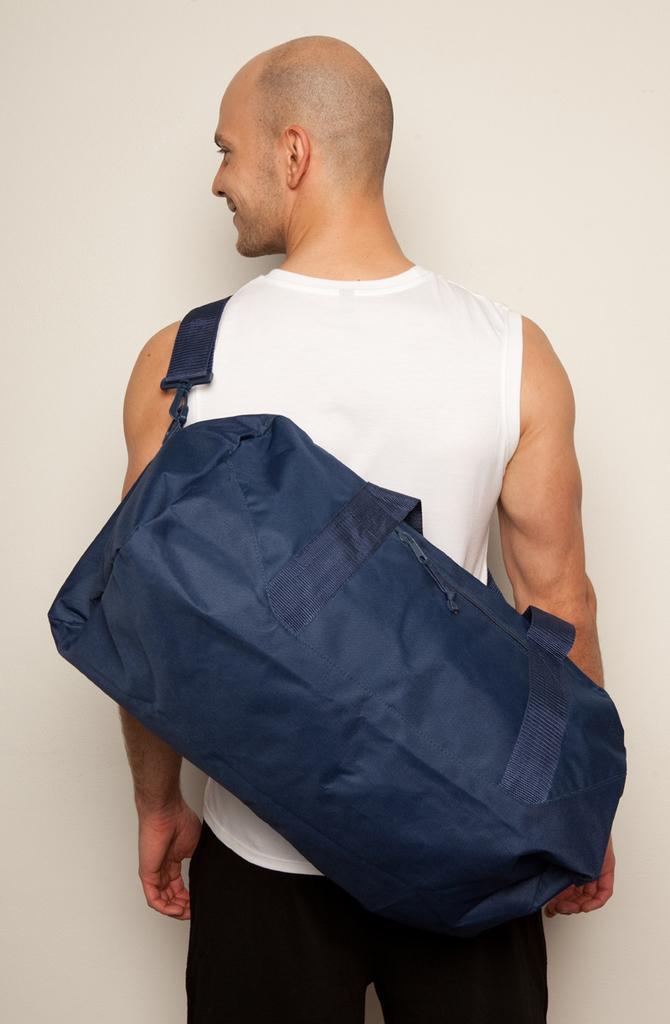In one or two sentences, can you explain what this image depicts? In this image I see a man who is wearing white tank top and black pants and I see that he is carrying a bag which is of blue in color and it is white in the background. 